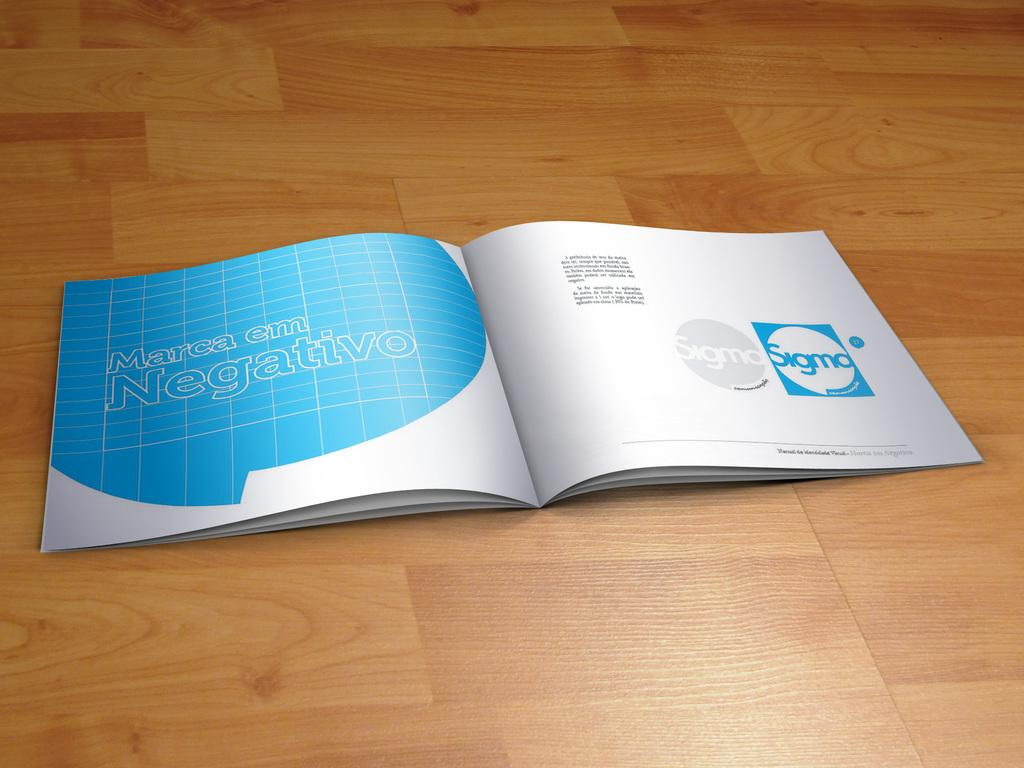<image>
Render a clear and concise summary of the photo. A thin booklet opened to a page that shows information for Sigma. 